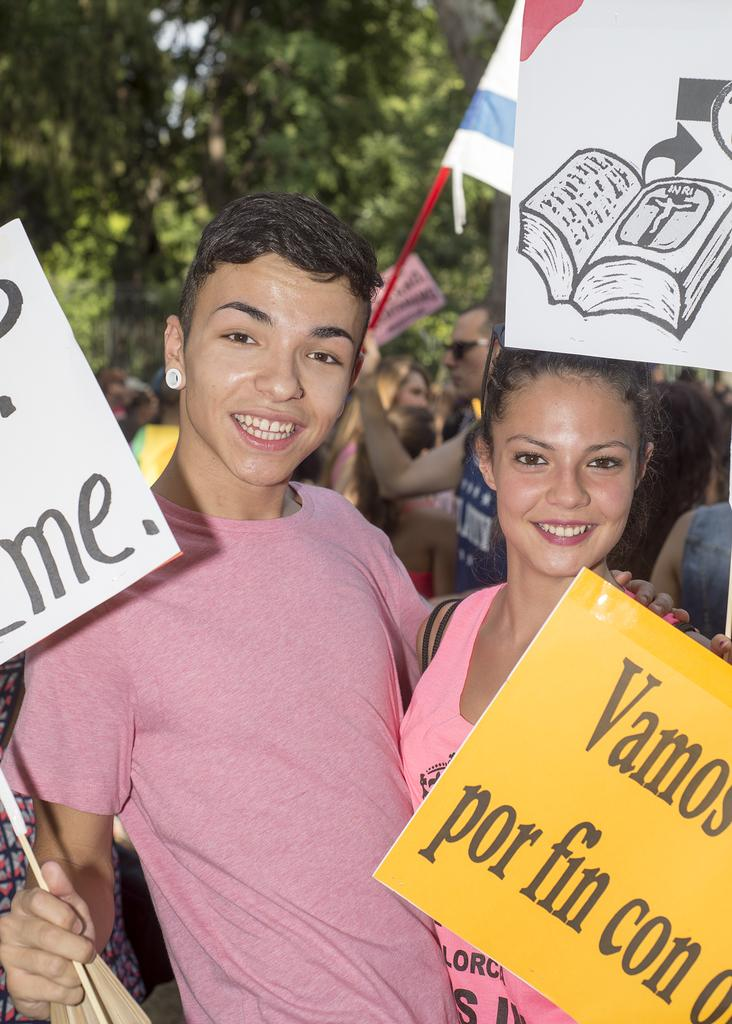How many people are present in the image? There are two people, a man and a woman, present in the image. What are the man and woman holding in the image? The man is holding a white board, and the woman is holding a yellow board. What can be seen in the background of the image? There are people and trees in the background of the image. What type of heart condition does the woman in the image have? There is no indication of a heart condition in the image, as it only shows a man and a woman holding boards. 